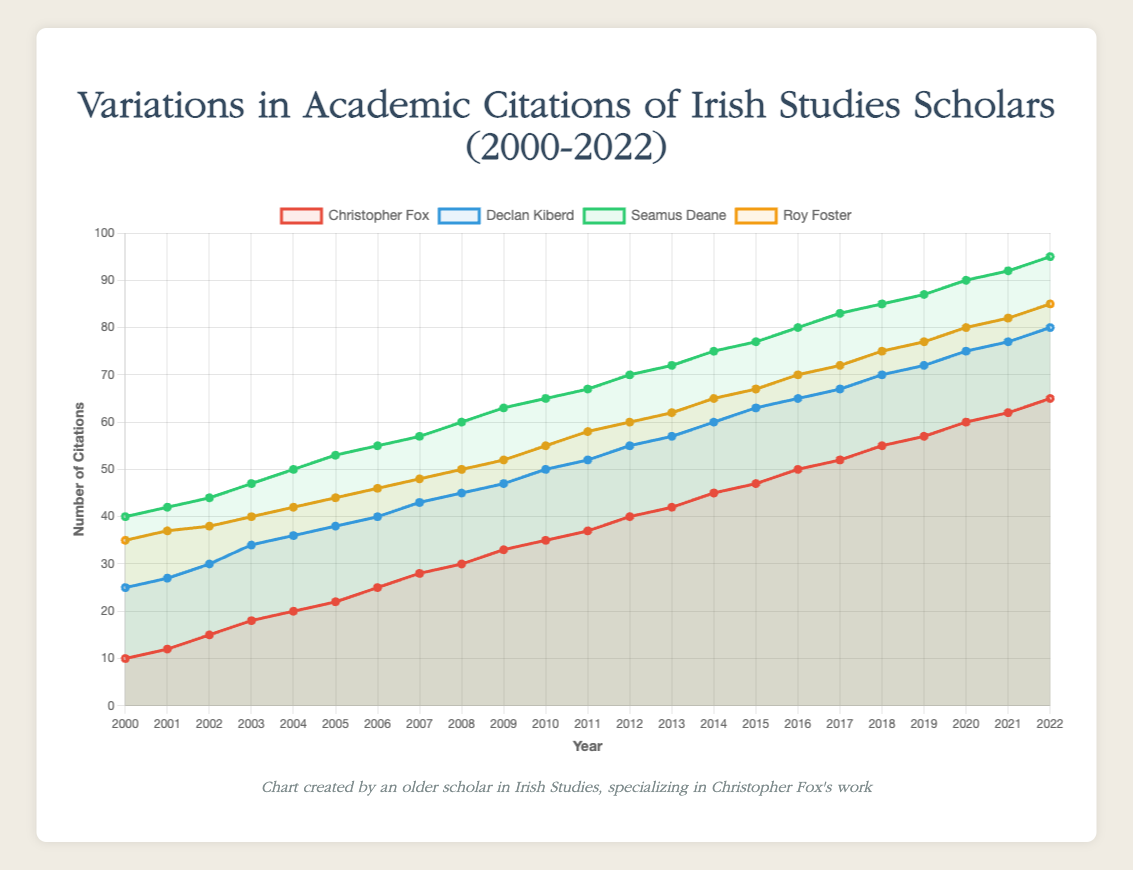What year did Christopher Fox surpass 50 citations? To determine the year Christopher Fox surpassed 50 citations, observe the red line representing his citations and find the point where it crosses above the 50-mark on the Y-axis. This happens in the year 2016.
Answer: 2016 Who had the highest citation count in 2010? Look at the data points for 2010 and compare the heights of the lines. Seamus Deane (green line) had the highest citation count of 65.
Answer: Seamus Deane How many total citations did Christopher Fox accumulate between 2000 and 2010? Sum the citations for Christopher Fox from the years 2000 to 2010: 10 + 12 + 15 + 18 + 20 + 22 + 25 + 28 + 30 + 33 + 35 = 248.
Answer: 248 In which year did the gap between Roy Foster and Seamus Deane’s citations become the smallest? Compare the gaps between the orange line representing Roy Foster and the green line representing Seamus Deane for each year. The smallest gap occurs in the year 2002, with a difference of 6 citations (44 for Seamus Deane and 38 for Roy Foster).
Answer: 2002 Who had more citations in 2006, Christopher Fox or Declan Kiberd? Compare the data points for Christopher Fox and Declan Kiberd in 2006. Christopher Fox had 25 citations and Declan Kiberd had 40 citations.
Answer: Declan Kiberd What was the average annual increase in citations for Christopher Fox from 2000 to 2022? Find the total increase in citations from 2000 (10 citations) to 2022 (65 citations), which is 65 - 10 = 55 citations over 22 years. The average annual increase is 55/22 = 2.5 citations per year.
Answer: 2.5 Which scholar’s citation trend shows the most consistent annual increase? Observe the lines for each scholar to see which one has the most consistent upward slope. Seamus Deane’s green line shows a consistent annual increase with fewer fluctuations.
Answer: Seamus Deane How many more citations did Seamus Deane receive in 2022 compared to 2000? Subtract Seamus Deane’s citations in 2000 (40) from his citations in 2022 (95), giving a difference of 95 - 40 = 55 citations.
Answer: 55 What is the difference between the highest and the lowest citation counts for Christopher Fox between 2000 and 2022? The highest citation count for Christopher Fox is 65 (in 2022), and the lowest is 10 (in 2000). The difference is 65 - 10 = 55.
Answer: 55 Which year did all four scholars gain citations, and Christopher Fox got the maximum citations for that year? Find the year where Christopher Fox has the maximum citations for that year among the four scholars. This occurs in 2022, where Christopher Fox has 65 citations, which is still lower than others' maximum ever. Christopher Fox surpasses others in a few initial years (2006) but they didn't gain citations that year. No year sees Fox at the top.
Answer: Never 